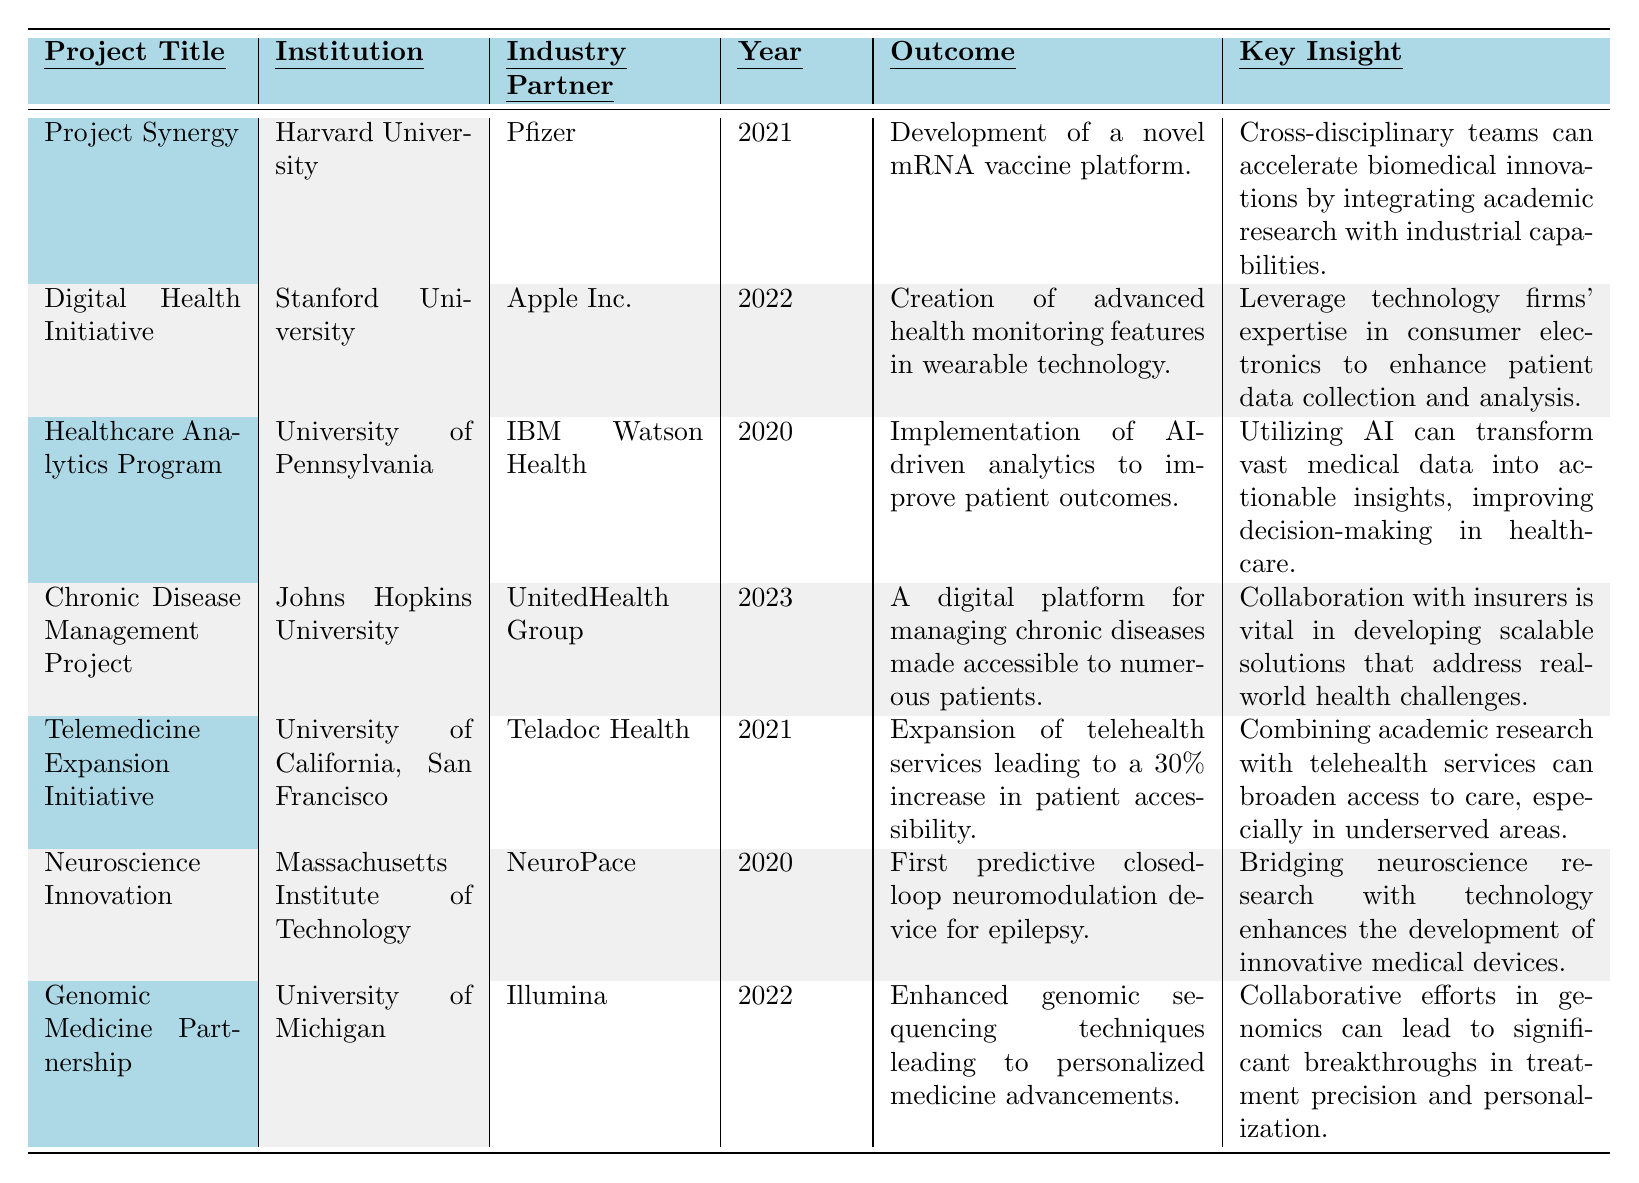What is the outcome of the "Chronic Disease Management Project"? The table states that the outcome for the "Chronic Disease Management Project" is "A digital platform for managing chronic diseases made accessible to numerous patients."
Answer: A digital platform for managing chronic diseases made accessible to numerous patients Which institution partnered with Apple Inc. in the "Digital Health Initiative"? According to the table, the institution that partnered with Apple Inc. for the "Digital Health Initiative" is Stanford University.
Answer: Stanford University In what year was the "Healthcare Analytics Program" implemented? The table reveals that the "Healthcare Analytics Program" was implemented in 2020.
Answer: 2020 What are the two key insights from the projects involving AI and telemedicine? The table lists the key insights from the "Healthcare Analytics Program" as "Utilizing AI can transform vast medical data into actionable insights," and from the "Telemedicine Expansion Initiative" as "Combining academic research with telehealth services can broaden access to care."
Answer: Utilizing AI can transform vast medical data into actionable insights; combining academic research with telehealth services can broaden access to care Which project had the earliest implementation year, and what was the outcome? Reviewing the years in the table, the earliest implementation year is 2020 for the "Healthcare Analytics Program," which had an outcome of "Implementation of AI-driven analytics to improve patient outcomes."
Answer: Healthcare Analytics Program; Implementation of AI-driven analytics to improve patient outcomes Is there a project from 2021 that involved a pharmaceutical company? Yes, the "Project Synergy" in 2021 involved Pfizer as the industry partner.
Answer: Yes How many projects in the table involved an institution from California? By checking the table, there are two projects involving institutions from California: the "Digital Health Initiative" from Stanford University and the "Telemedicine Expansion Initiative" from the University of California, San Francisco.
Answer: 2 What is the latest project listed in the table and its outcome? The table shows that the latest project is the "Chronic Disease Management Project," which has the outcome of "A digital platform for managing chronic diseases made accessible to numerous patients."
Answer: Chronic Disease Management Project; A digital platform for managing chronic diseases made accessible to numerous patients What industry partner collaborated with the University of Michigan in 2022? The table indicates that the industry partner who collaborated with the University of Michigan in 2022 is Illumina.
Answer: Illumina Which project resulted in a significant increase in patient accessibility, and by how much? According to the table, the "Telemedicine Expansion Initiative" resulted in a 30% increase in patient accessibility.
Answer: Telemedicine Expansion Initiative; 30% increase in patient accessibility What common theme can be observed in the key insights from projects involving industry partners? Reviewing the key insights indicates a common theme of collaboration between academic research and industry capabilities to address real-world challenges and innovations in healthcare.
Answer: Collaboration to address real-world challenges and innovations in healthcare 